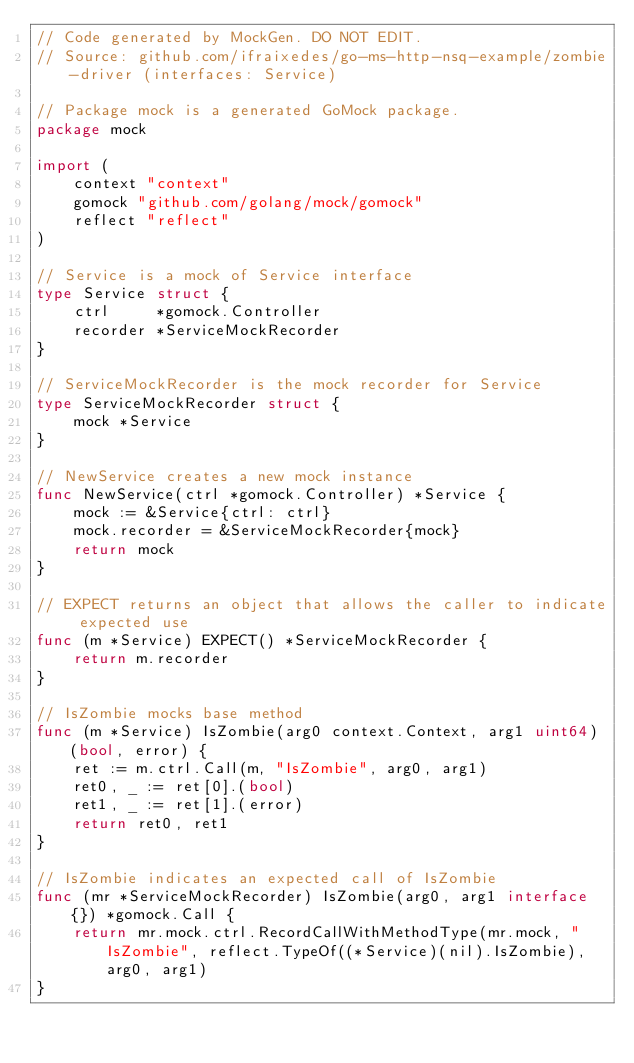<code> <loc_0><loc_0><loc_500><loc_500><_Go_>// Code generated by MockGen. DO NOT EDIT.
// Source: github.com/ifraixedes/go-ms-http-nsq-example/zombie-driver (interfaces: Service)

// Package mock is a generated GoMock package.
package mock

import (
	context "context"
	gomock "github.com/golang/mock/gomock"
	reflect "reflect"
)

// Service is a mock of Service interface
type Service struct {
	ctrl     *gomock.Controller
	recorder *ServiceMockRecorder
}

// ServiceMockRecorder is the mock recorder for Service
type ServiceMockRecorder struct {
	mock *Service
}

// NewService creates a new mock instance
func NewService(ctrl *gomock.Controller) *Service {
	mock := &Service{ctrl: ctrl}
	mock.recorder = &ServiceMockRecorder{mock}
	return mock
}

// EXPECT returns an object that allows the caller to indicate expected use
func (m *Service) EXPECT() *ServiceMockRecorder {
	return m.recorder
}

// IsZombie mocks base method
func (m *Service) IsZombie(arg0 context.Context, arg1 uint64) (bool, error) {
	ret := m.ctrl.Call(m, "IsZombie", arg0, arg1)
	ret0, _ := ret[0].(bool)
	ret1, _ := ret[1].(error)
	return ret0, ret1
}

// IsZombie indicates an expected call of IsZombie
func (mr *ServiceMockRecorder) IsZombie(arg0, arg1 interface{}) *gomock.Call {
	return mr.mock.ctrl.RecordCallWithMethodType(mr.mock, "IsZombie", reflect.TypeOf((*Service)(nil).IsZombie), arg0, arg1)
}
</code> 